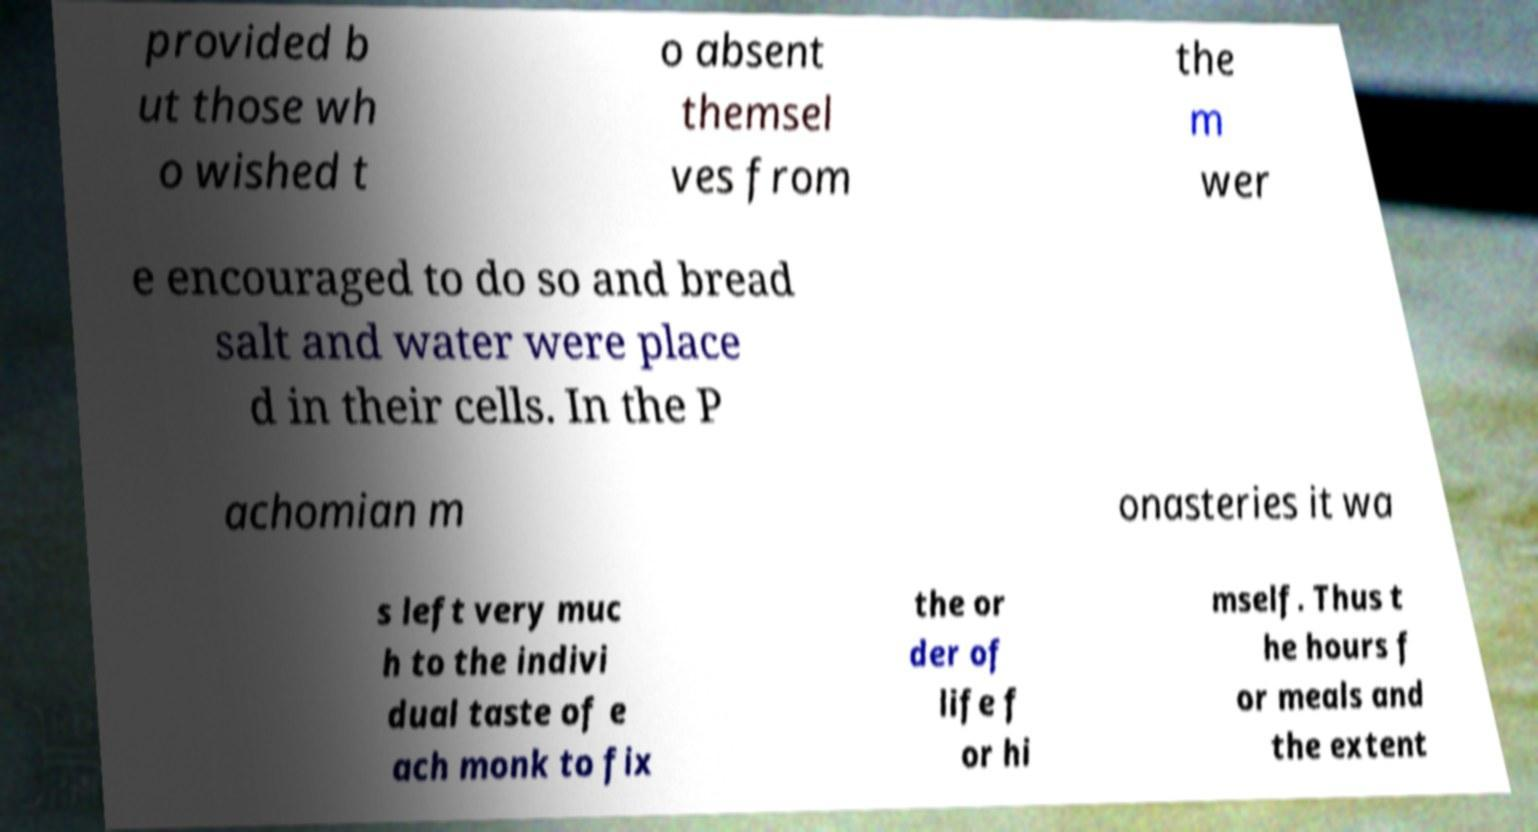Can you accurately transcribe the text from the provided image for me? provided b ut those wh o wished t o absent themsel ves from the m wer e encouraged to do so and bread salt and water were place d in their cells. In the P achomian m onasteries it wa s left very muc h to the indivi dual taste of e ach monk to fix the or der of life f or hi mself. Thus t he hours f or meals and the extent 